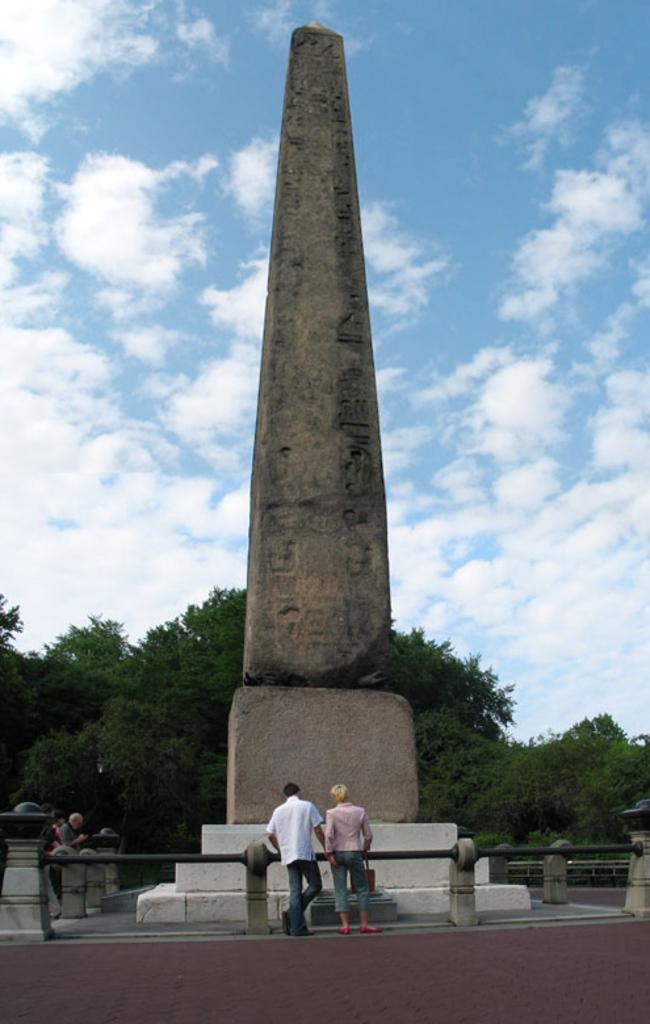How would you summarize this image in a sentence or two? In this image, we can see a pillar, rods with poles. Few people are standing here. At the bottom, there is a footpath. Background there are so many trees and cloudy sky. 